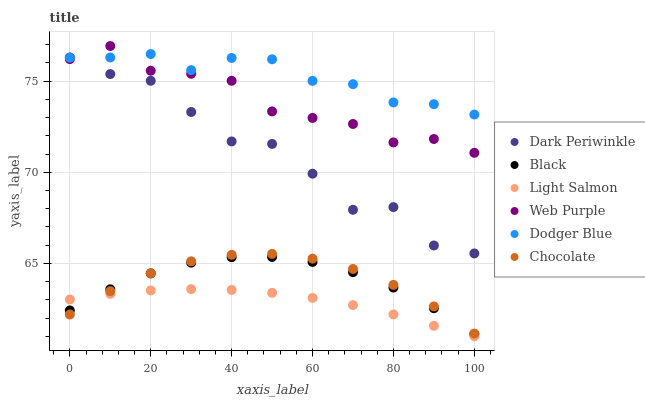Does Light Salmon have the minimum area under the curve?
Answer yes or no. Yes. Does Dodger Blue have the maximum area under the curve?
Answer yes or no. Yes. Does Chocolate have the minimum area under the curve?
Answer yes or no. No. Does Chocolate have the maximum area under the curve?
Answer yes or no. No. Is Light Salmon the smoothest?
Answer yes or no. Yes. Is Dark Periwinkle the roughest?
Answer yes or no. Yes. Is Chocolate the smoothest?
Answer yes or no. No. Is Chocolate the roughest?
Answer yes or no. No. Does Light Salmon have the lowest value?
Answer yes or no. Yes. Does Chocolate have the lowest value?
Answer yes or no. No. Does Web Purple have the highest value?
Answer yes or no. Yes. Does Chocolate have the highest value?
Answer yes or no. No. Is Chocolate less than Dark Periwinkle?
Answer yes or no. Yes. Is Dodger Blue greater than Black?
Answer yes or no. Yes. Does Chocolate intersect Black?
Answer yes or no. Yes. Is Chocolate less than Black?
Answer yes or no. No. Is Chocolate greater than Black?
Answer yes or no. No. Does Chocolate intersect Dark Periwinkle?
Answer yes or no. No. 